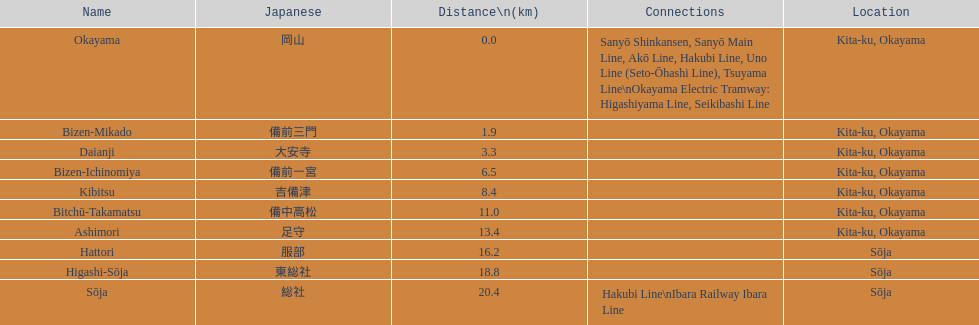What is the count of stations less than 15km away? 7. 